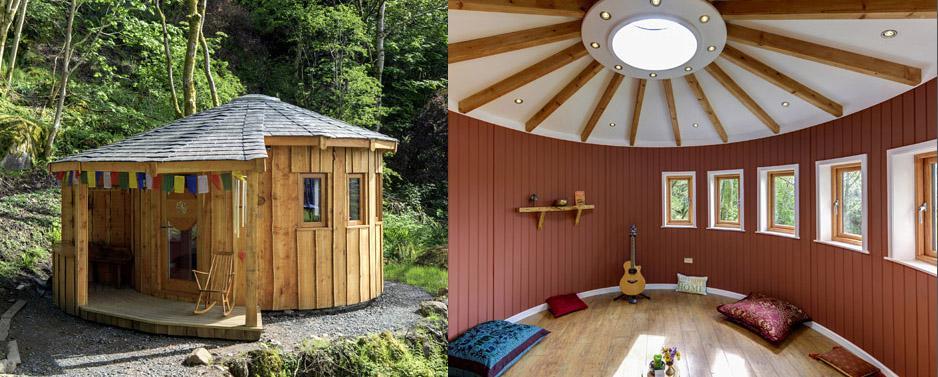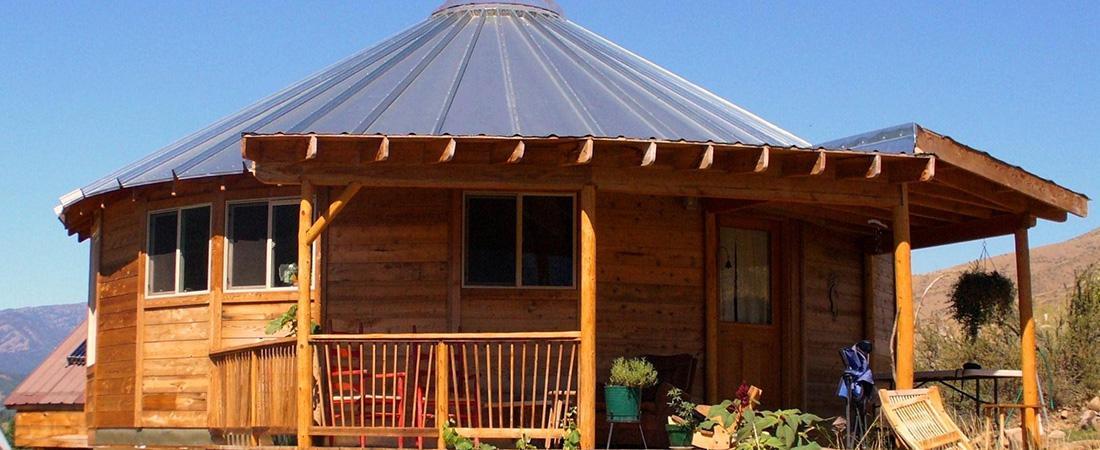The first image is the image on the left, the second image is the image on the right. Assess this claim about the two images: "A round house in one image has a metal roof with fan-shaped segments.". Correct or not? Answer yes or no. Yes. 